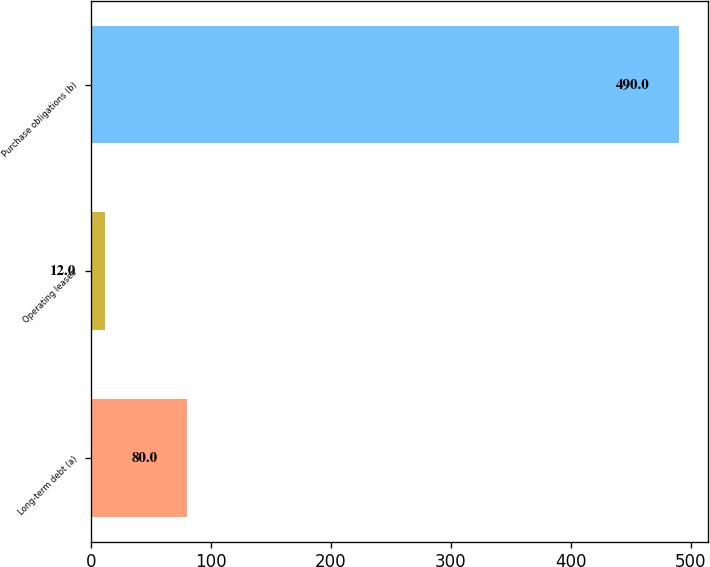<chart> <loc_0><loc_0><loc_500><loc_500><bar_chart><fcel>Long-term debt (a)<fcel>Operating leases<fcel>Purchase obligations (b)<nl><fcel>80<fcel>12<fcel>490<nl></chart> 